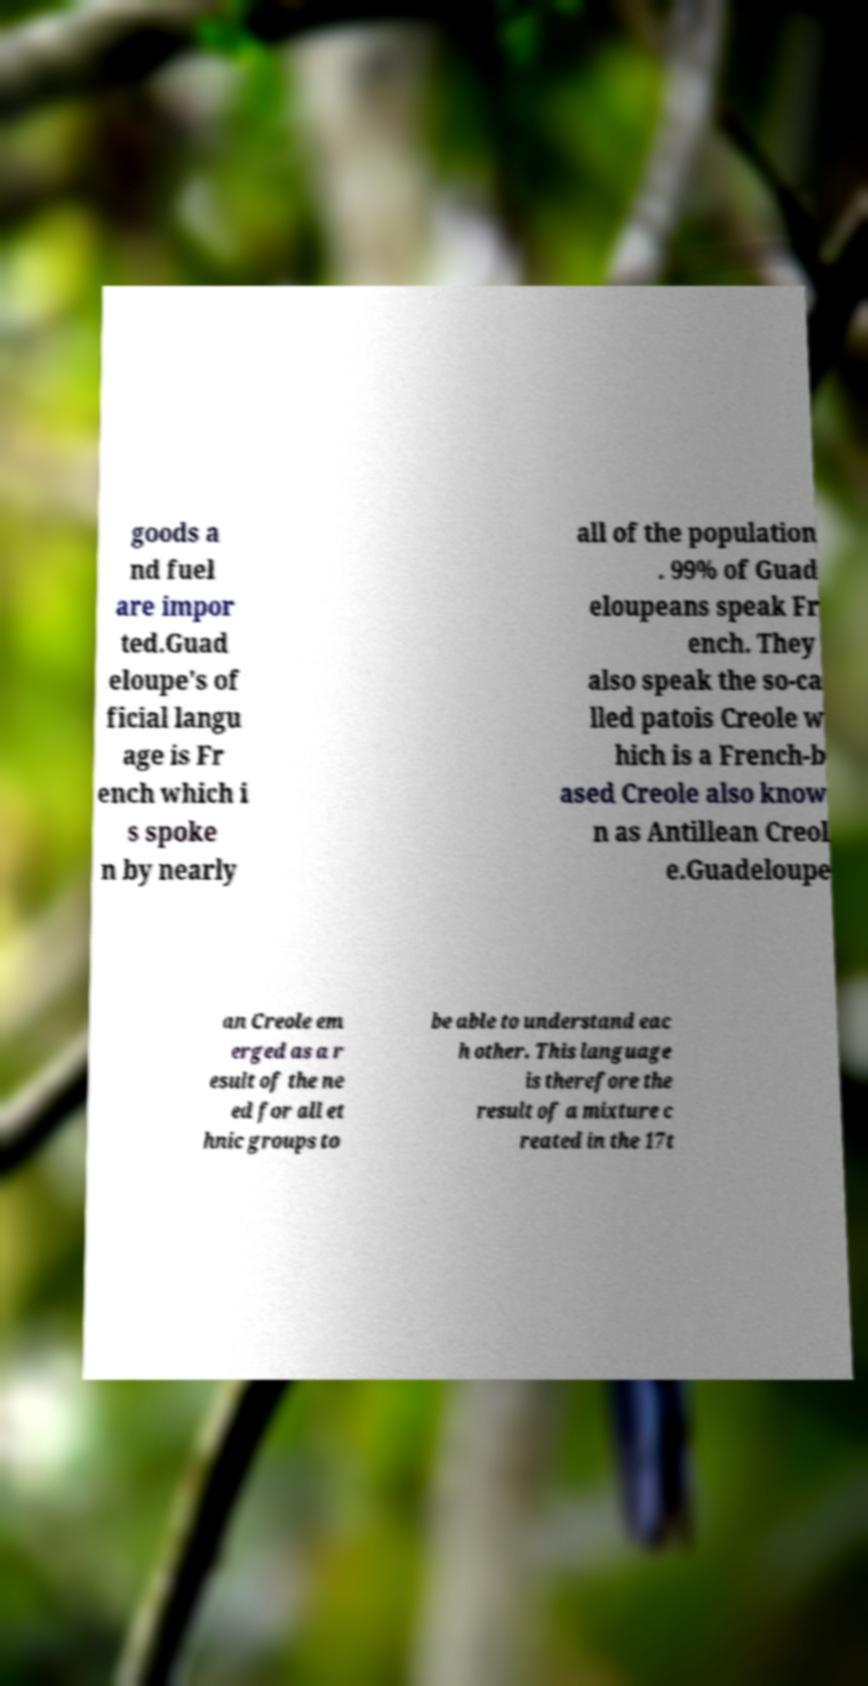Please read and relay the text visible in this image. What does it say? goods a nd fuel are impor ted.Guad eloupe's of ficial langu age is Fr ench which i s spoke n by nearly all of the population . 99% of Guad eloupeans speak Fr ench. They also speak the so-ca lled patois Creole w hich is a French-b ased Creole also know n as Antillean Creol e.Guadeloupe an Creole em erged as a r esult of the ne ed for all et hnic groups to be able to understand eac h other. This language is therefore the result of a mixture c reated in the 17t 